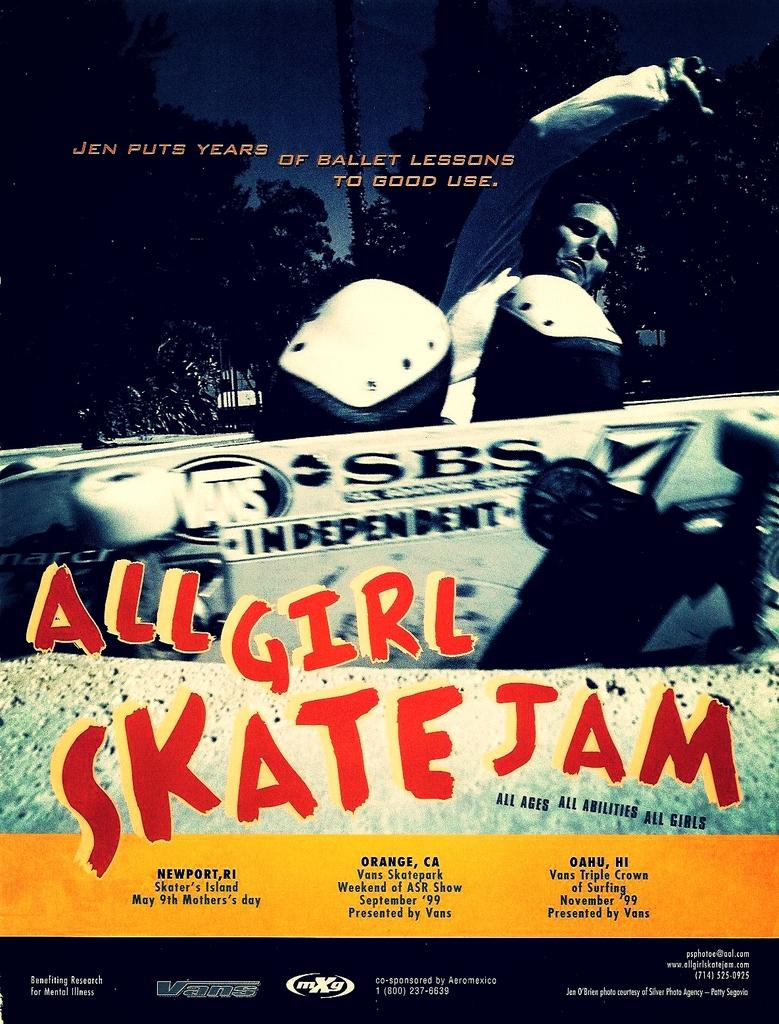<image>
Present a compact description of the photo's key features. a poster that says 'all girl skate jam' on it 